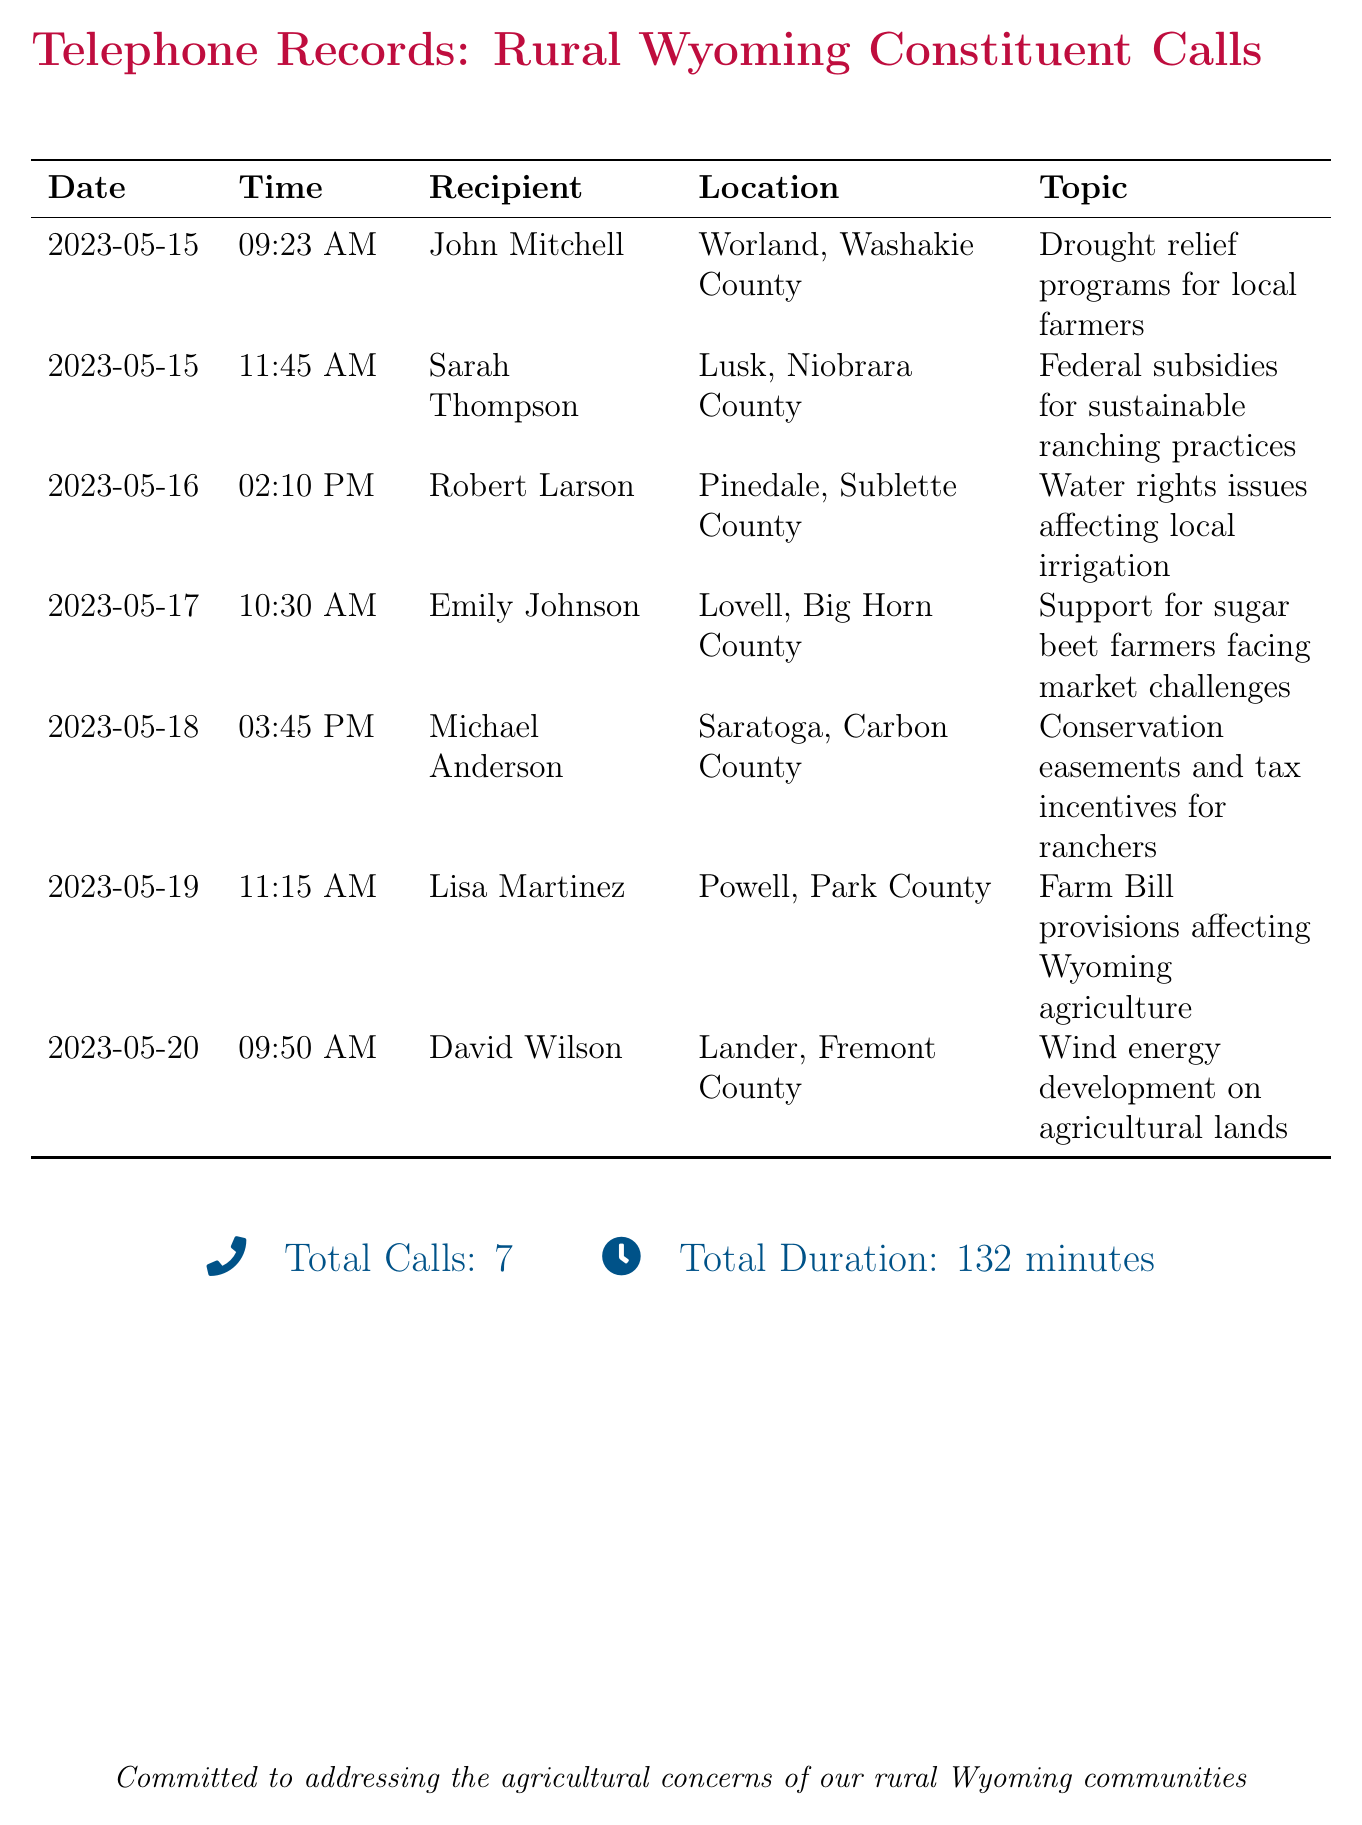What was the date of the first call? The date of the first call recorded in the document is the earliest date listed in the calls, which is May 15, 2023.
Answer: May 15, 2023 How many calls were made to Lusk, Niobrara County? The document lists the recipient locations and shows that only one call was made to Lusk, Niobrara County.
Answer: 1 What time did the call to Michael Anderson take place? The time of the call to Michael Anderson can be found in the corresponding row in the table, which is listed under the time column.
Answer: 03:45 PM Which topic was discussed with Robert Larson? The specific topic discussed during the call with Robert Larson can be located in the topic column associated with his name.
Answer: Water rights issues affecting local irrigation How many total minutes did the calls last? The total duration of all the calls is provided in the summary at the bottom of the document, which includes the cumulative time of all calls.
Answer: 132 minutes What was the top concern discussed with John Mitchell? The main concern of the call with John Mitchell is stated directly in the document, under the topic column related to his name.
Answer: Drought relief programs for local farmers Which county was the recipient Sarah Thompson from? The county associated with Sarah Thompson can be found in the location column next to her name in the list of calls.
Answer: Niobrara County Was any call made regarding wind energy development? The calls listed in the document specify topics, and one of them directly discusses wind energy development.
Answer: Yes 